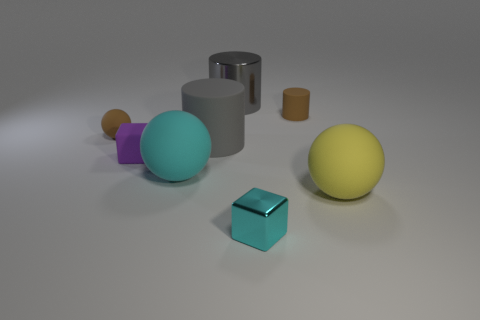What number of other objects are there of the same material as the cyan block?
Provide a succinct answer. 1. Is the number of tiny green cylinders greater than the number of big gray cylinders?
Provide a short and direct response. No. What is the material of the sphere that is to the right of the large gray cylinder that is behind the gray object in front of the brown ball?
Keep it short and to the point. Rubber. Does the small cylinder have the same color as the tiny sphere?
Make the answer very short. Yes. Is there a sphere that has the same color as the small metallic block?
Give a very brief answer. Yes. There is a cyan object that is the same size as the brown rubber cylinder; what is its shape?
Your answer should be compact. Cube. Is the number of gray metallic things less than the number of large green cylinders?
Your response must be concise. No. What number of other cubes are the same size as the shiny cube?
Your answer should be very brief. 1. There is a object that is the same color as the large matte cylinder; what shape is it?
Your answer should be very brief. Cylinder. What is the material of the purple cube?
Offer a terse response. Rubber. 